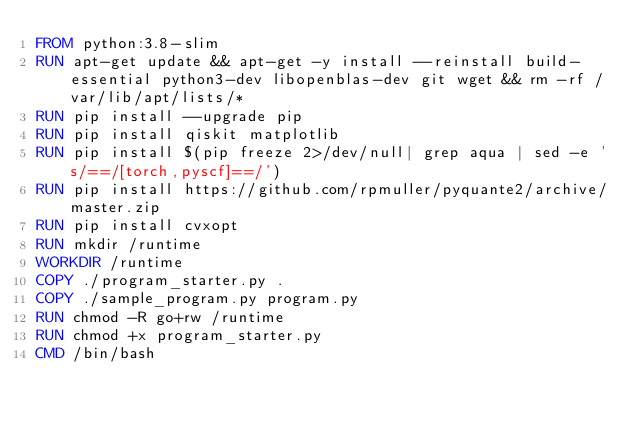Convert code to text. <code><loc_0><loc_0><loc_500><loc_500><_Dockerfile_>FROM python:3.8-slim
RUN apt-get update && apt-get -y install --reinstall build-essential python3-dev libopenblas-dev git wget && rm -rf /var/lib/apt/lists/*
RUN pip install --upgrade pip
RUN pip install qiskit matplotlib
RUN pip install $(pip freeze 2>/dev/null| grep aqua | sed -e 's/==/[torch,pyscf]==/')
RUN pip install https://github.com/rpmuller/pyquante2/archive/master.zip
RUN pip install cvxopt
RUN mkdir /runtime
WORKDIR /runtime
COPY ./program_starter.py .
COPY ./sample_program.py program.py
RUN chmod -R go+rw /runtime
RUN chmod +x program_starter.py
CMD /bin/bash
</code> 